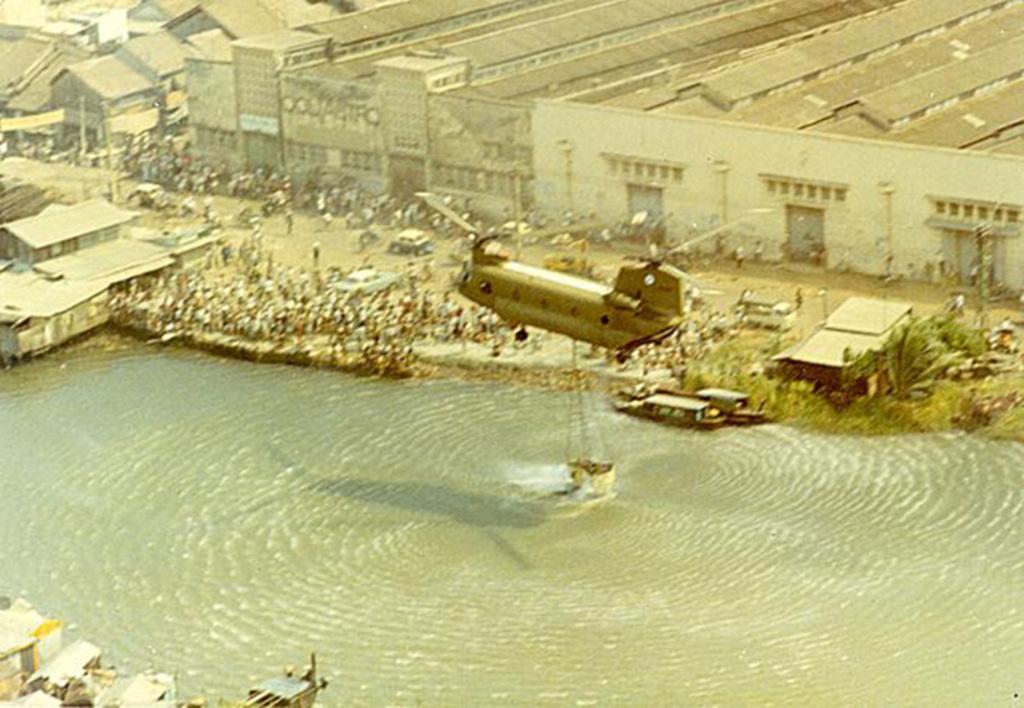How would you summarize this image in a sentence or two? In this picture, we can see a few people, water, aircraft with some object attached to it, we can see buildings, trees, and poles. 